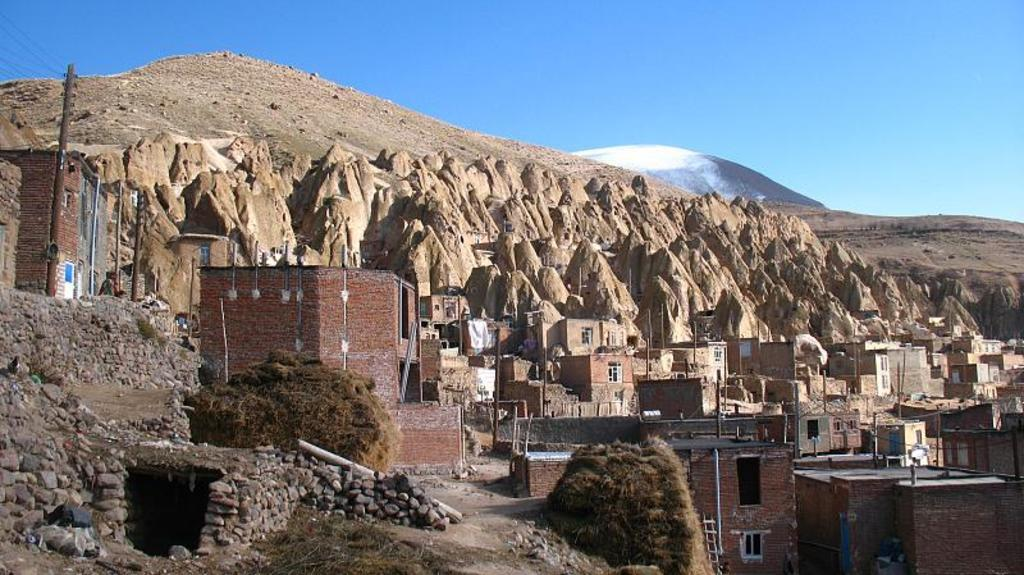What type of structures can be seen in the image? There are houses and buildings in the image. What natural elements are present in the image? There are plants, rocks, and hills in the image. What is visible at the top of the image? The sky is visible at the top of the image. Can you describe the stranger who is attacking the train in the image? There is no stranger or train present in the image. The image features houses, buildings, plants, rocks, hills, and a visible sky. 